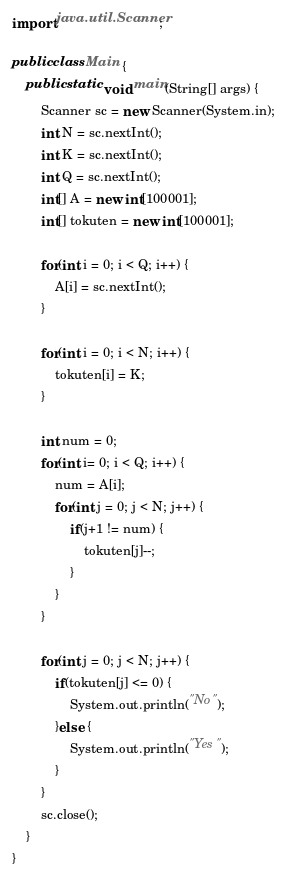Convert code to text. <code><loc_0><loc_0><loc_500><loc_500><_Java_>import java.util.Scanner;

public class Main {
	public static void main(String[] args) {
		Scanner sc = new Scanner(System.in);
		int N = sc.nextInt();
		int K = sc.nextInt();
		int Q = sc.nextInt();
		int[] A = new int[100001];
		int[] tokuten = new int[100001];
		
		for(int i = 0; i < Q; i++) {
			A[i] = sc.nextInt();
		}
		
		for(int i = 0; i < N; i++) {
			tokuten[i] = K;
		}
		
		int num = 0;
		for(int i= 0; i < Q; i++) {
			num = A[i];
			for(int j = 0; j < N; j++) {
				if(j+1 != num) {
					tokuten[j]--;
				}
			}
		}
		
		for(int j = 0; j < N; j++) {
			if(tokuten[j] <= 0) {
				System.out.println("No");
			}else {
				System.out.println("Yes");
			}
		}
		sc.close();
	}
}
</code> 